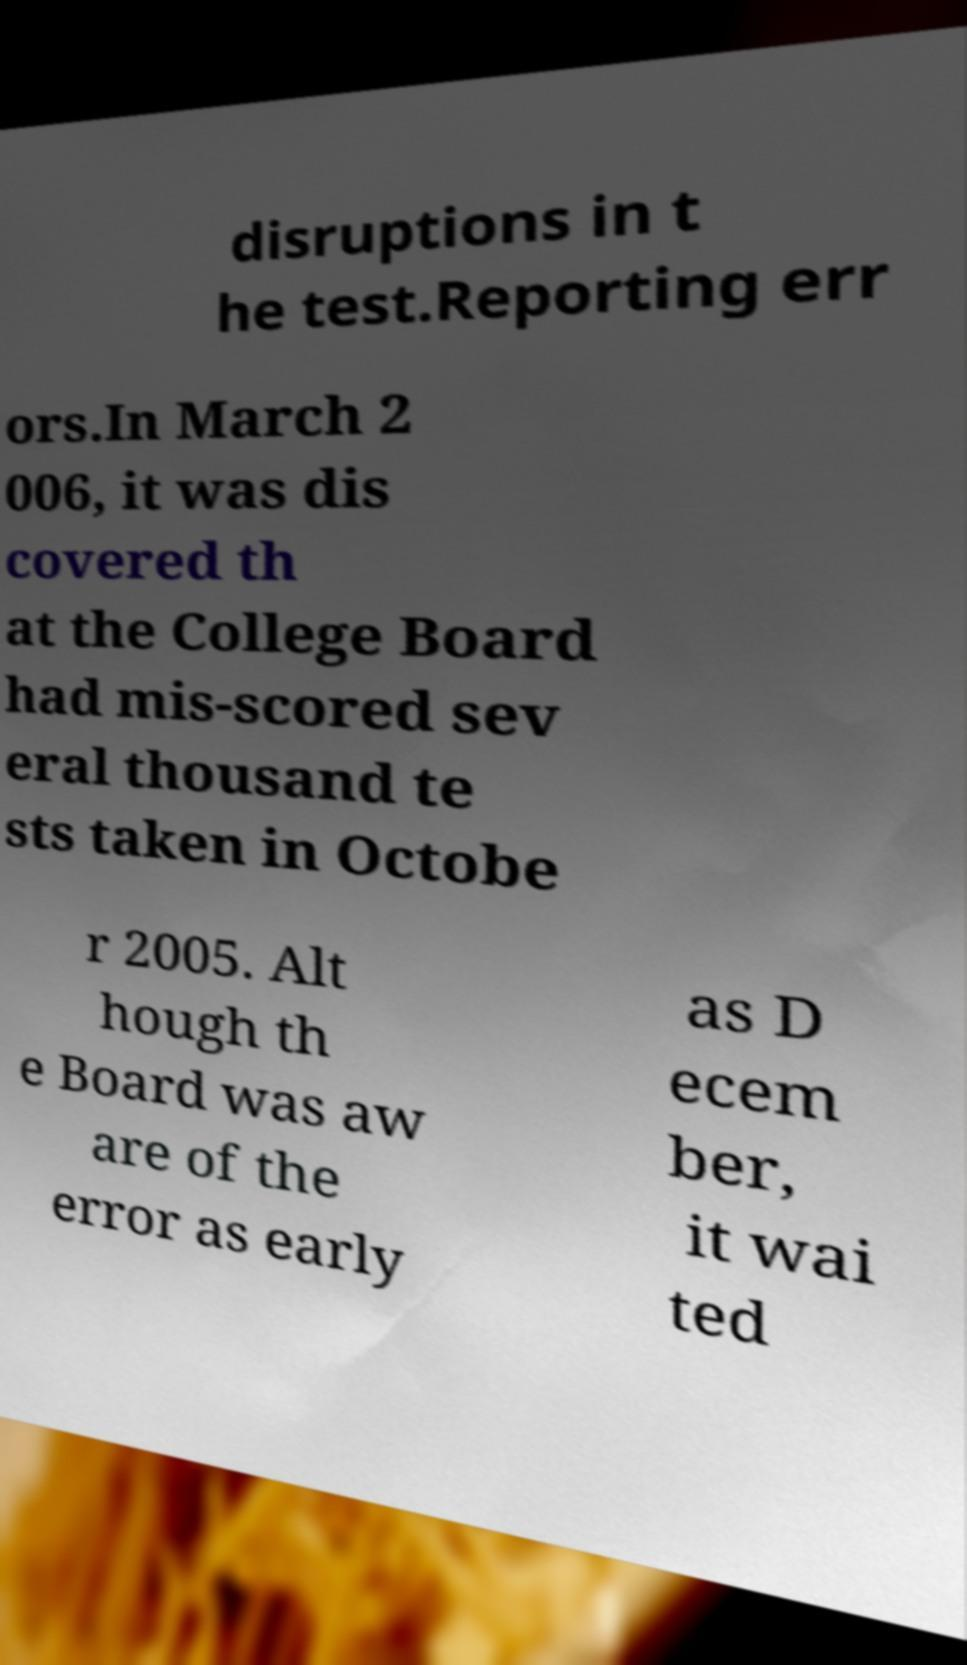Please read and relay the text visible in this image. What does it say? disruptions in t he test.Reporting err ors.In March 2 006, it was dis covered th at the College Board had mis-scored sev eral thousand te sts taken in Octobe r 2005. Alt hough th e Board was aw are of the error as early as D ecem ber, it wai ted 